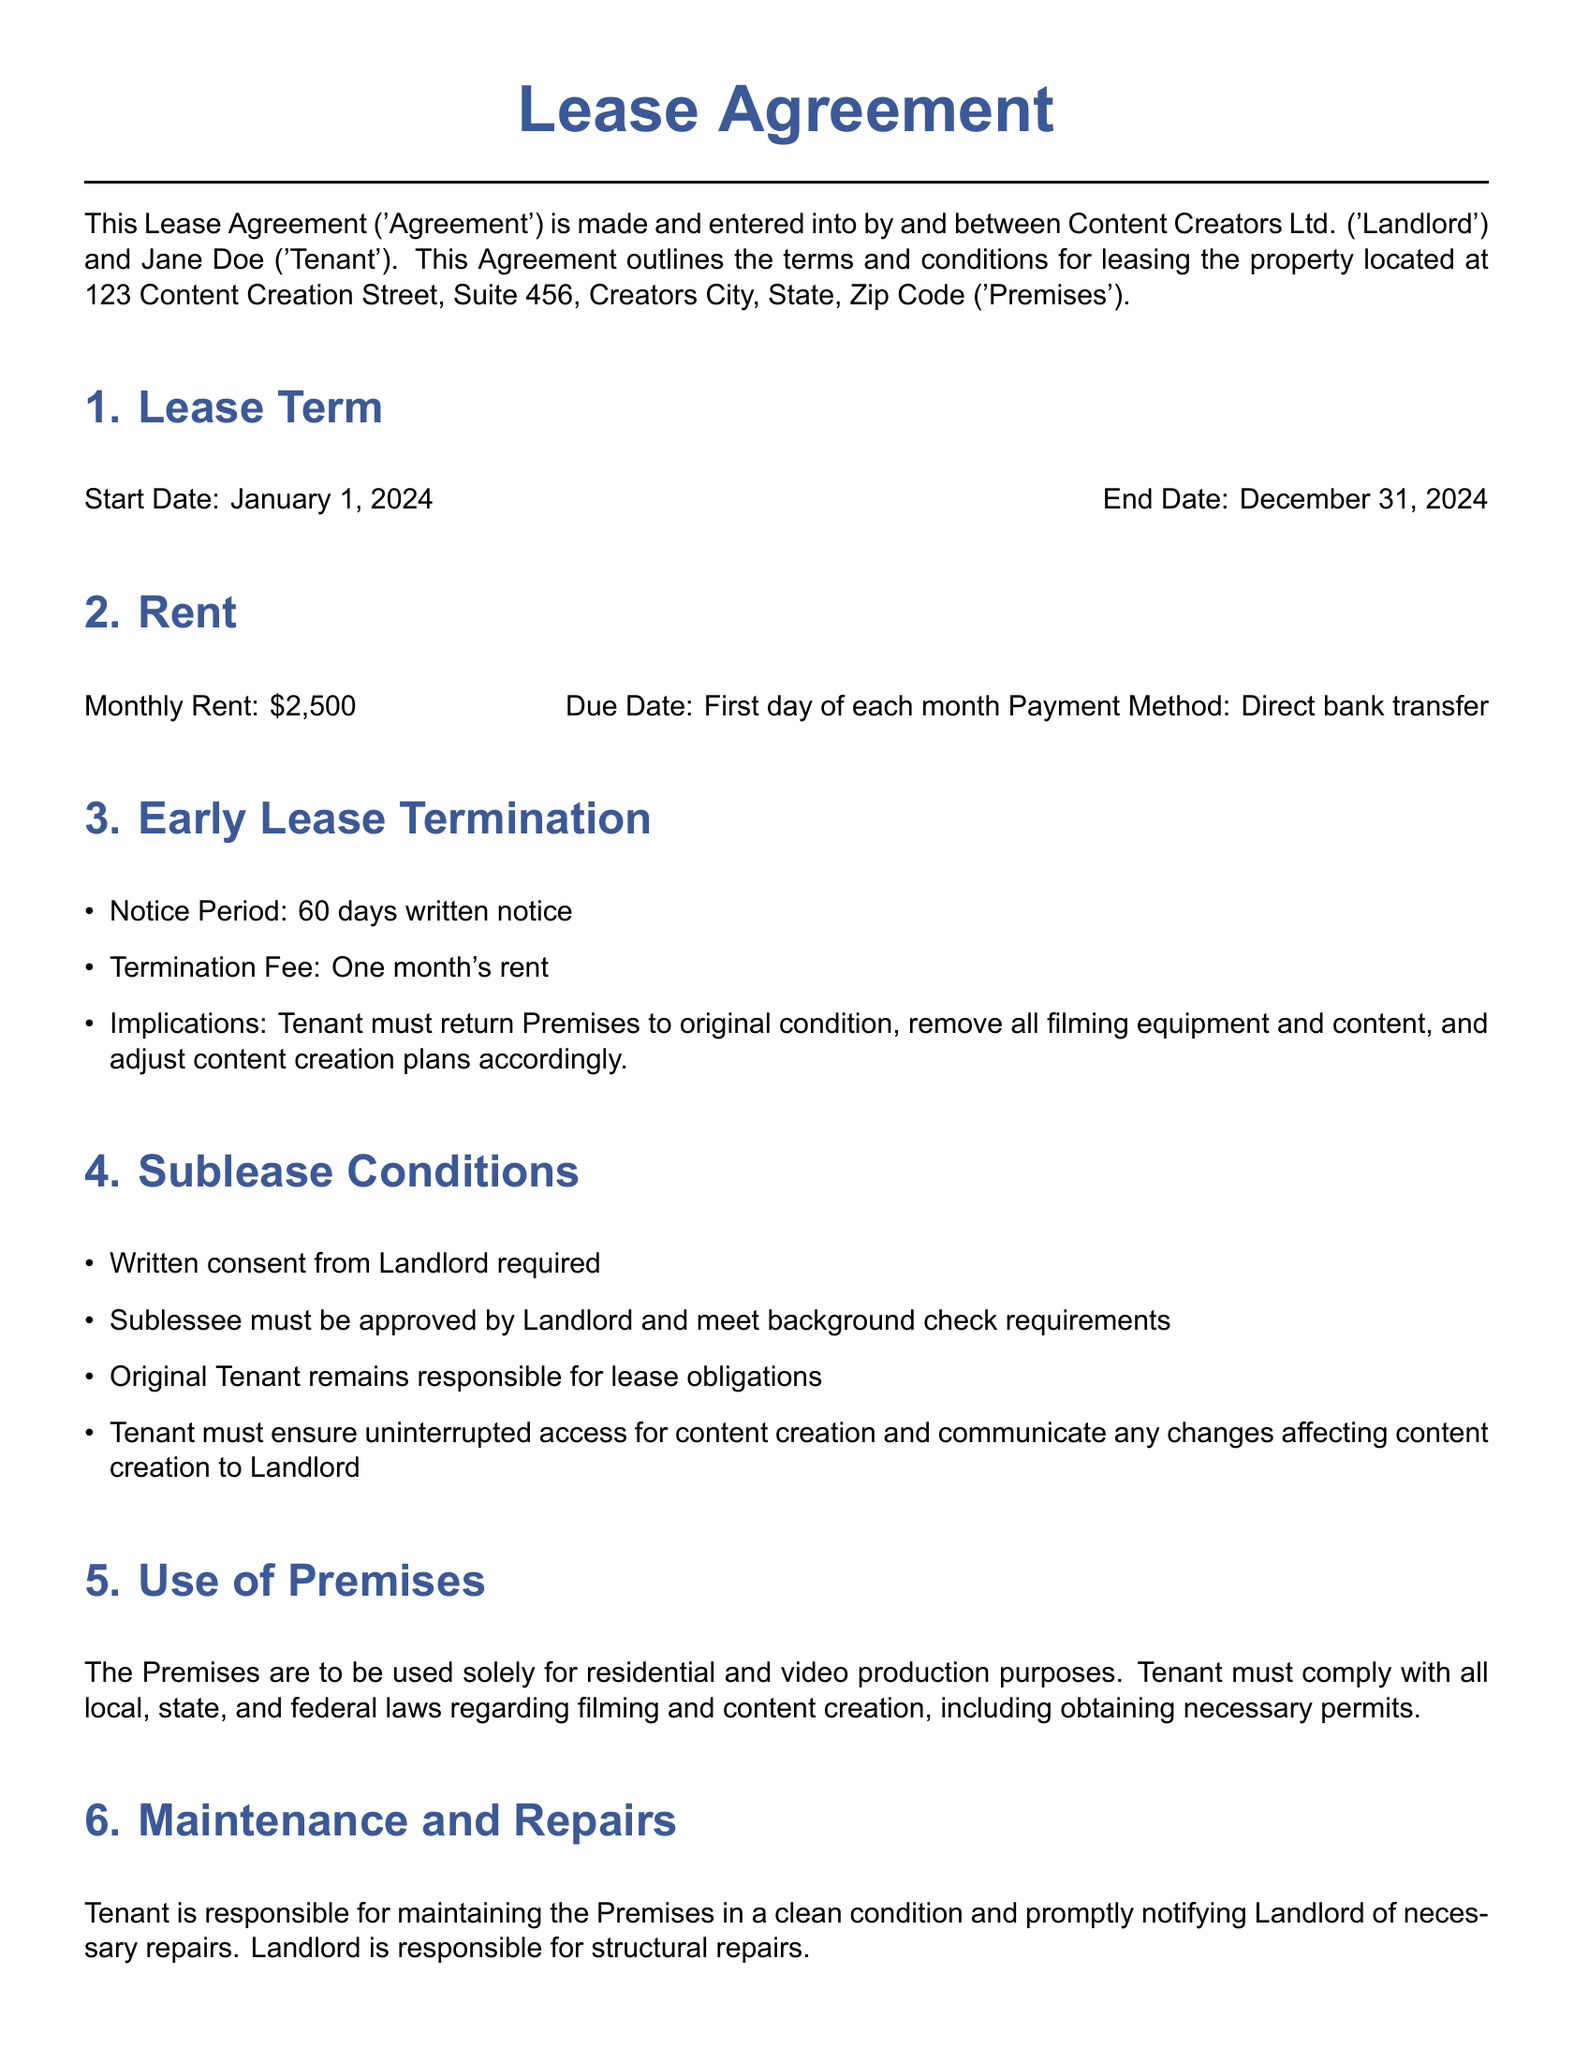What is the lease start date? The lease start date is specified in the agreement, which is January 1, 2024.
Answer: January 1, 2024 What is the monthly rent amount? The monthly rent is explicitly mentioned in the document, which is $2,500.
Answer: $2,500 How much notice is required for early lease termination? The document states that a 60 days written notice is required for early lease termination.
Answer: 60 days What is the termination fee for ending the lease early? The termination fee is outlined as one month's rent in the agreement.
Answer: One month's rent What must the Tenant do upon early lease termination? The implications state that the Tenant must return the Premises to original condition and remove all filming equipment.
Answer: Return Premises to original condition, remove filming equipment What must the Tenant obtain before subleasing? The Tenant is required to obtain written consent from the Landlord before subleasing the Premises.
Answer: Written consent What type of insurance must the Tenant maintain? The Tenant is required to maintain renter's insurance covering personal property and liability.
Answer: Renter's insurance What is the primary use of the Premises according to the agreement? The Premises are designated for residential and video production purposes as stated in the document.
Answer: Residential and video production purposes Who is responsible for maintenance and repairs of the Premises? The agreement specifies that the Tenant is responsible for maintaining the Premises in a clean condition.
Answer: Tenant 